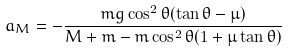<formula> <loc_0><loc_0><loc_500><loc_500>a _ { M } = - \frac { m g \cos ^ { 2 } \theta ( \tan \theta - \mu ) } { M + m - m \cos ^ { 2 } \theta ( 1 + \mu \tan \theta ) }</formula> 